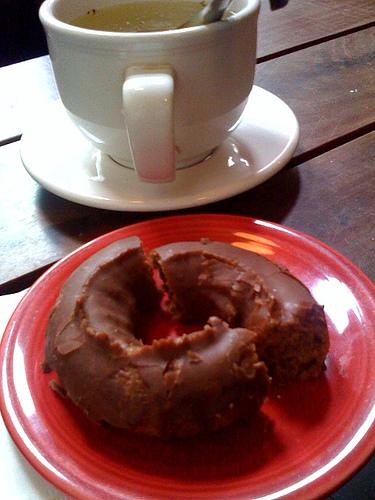What color is the plate with the doughnut?
Answer briefly. Red. How many donuts are on the plate?
Write a very short answer. 1. What food is shown?
Be succinct. Donut. 